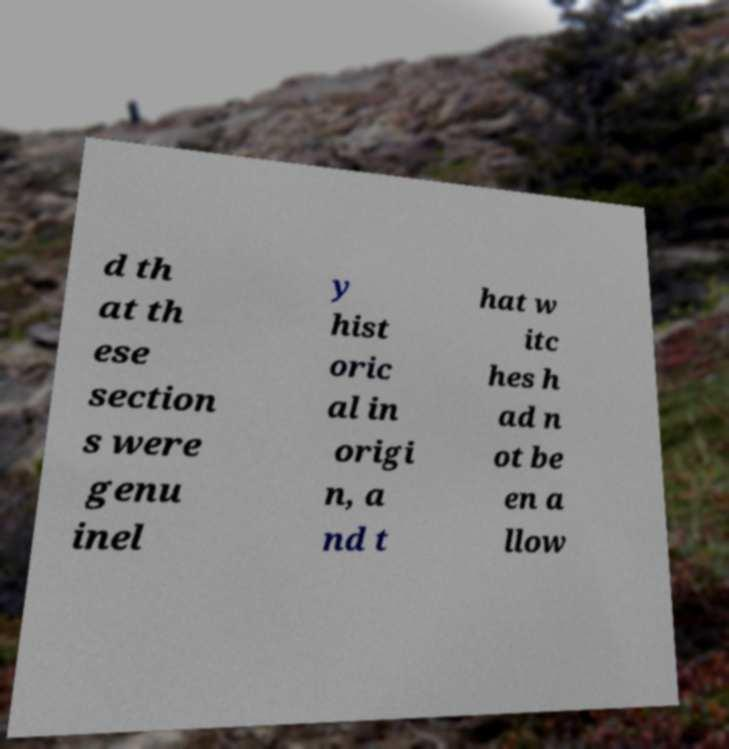Could you assist in decoding the text presented in this image and type it out clearly? d th at th ese section s were genu inel y hist oric al in origi n, a nd t hat w itc hes h ad n ot be en a llow 